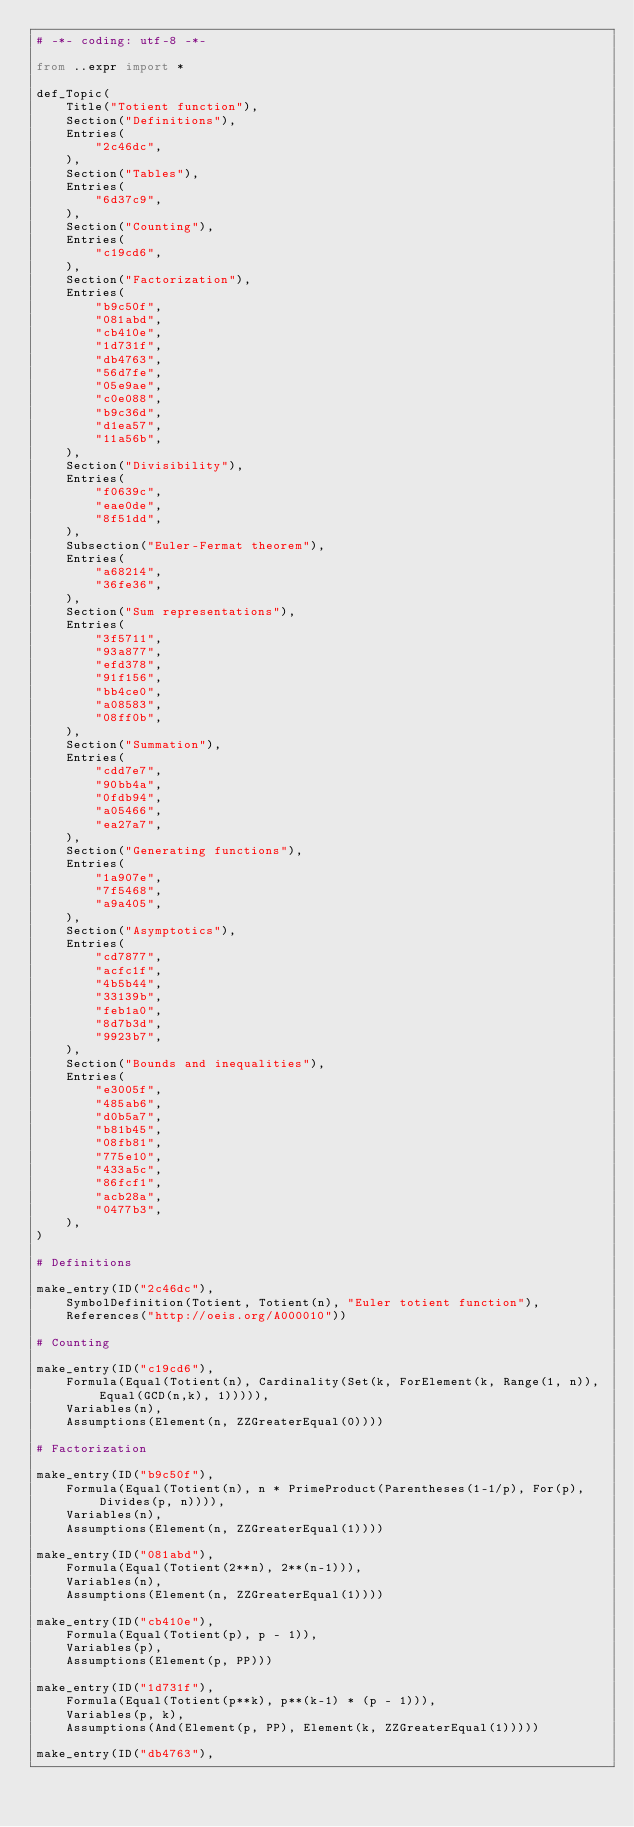<code> <loc_0><loc_0><loc_500><loc_500><_Python_># -*- coding: utf-8 -*-

from ..expr import *

def_Topic(
    Title("Totient function"),
    Section("Definitions"),
    Entries(
        "2c46dc",
    ),
    Section("Tables"),
    Entries(
        "6d37c9",
    ),
    Section("Counting"),
    Entries(
        "c19cd6",
    ),
    Section("Factorization"),
    Entries(
        "b9c50f",
        "081abd",
        "cb410e",
        "1d731f",
        "db4763",
        "56d7fe",
        "05e9ae",
        "c0e088",
        "b9c36d",
        "d1ea57",
        "11a56b",
    ),
    Section("Divisibility"),
    Entries(
        "f0639c",
        "eae0de",
        "8f51dd",
    ),
    Subsection("Euler-Fermat theorem"),
    Entries(
        "a68214",
        "36fe36",
    ),
    Section("Sum representations"),
    Entries(
        "3f5711",
        "93a877",
        "efd378",
        "91f156",
        "bb4ce0",
        "a08583",
        "08ff0b",
    ),
    Section("Summation"),
    Entries(
        "cdd7e7",
        "90bb4a",
        "0fdb94",
        "a05466",
        "ea27a7",
    ),
    Section("Generating functions"),
    Entries(
        "1a907e",
        "7f5468",
        "a9a405",
    ),
    Section("Asymptotics"),
    Entries(
        "cd7877",
        "acfc1f",
        "4b5b44",
        "33139b",
        "feb1a0",
        "8d7b3d",
        "9923b7",
    ),
    Section("Bounds and inequalities"),
    Entries(
        "e3005f",
        "485ab6",
        "d0b5a7",
        "b81b45",
        "08fb81",
        "775e10",
        "433a5c",
        "86fcf1",
        "acb28a",
        "0477b3",
    ),
)

# Definitions

make_entry(ID("2c46dc"),
    SymbolDefinition(Totient, Totient(n), "Euler totient function"),
    References("http://oeis.org/A000010"))

# Counting

make_entry(ID("c19cd6"),
    Formula(Equal(Totient(n), Cardinality(Set(k, ForElement(k, Range(1, n)), Equal(GCD(n,k), 1))))),
    Variables(n),
    Assumptions(Element(n, ZZGreaterEqual(0))))

# Factorization

make_entry(ID("b9c50f"),
    Formula(Equal(Totient(n), n * PrimeProduct(Parentheses(1-1/p), For(p), Divides(p, n)))),
    Variables(n),
    Assumptions(Element(n, ZZGreaterEqual(1))))

make_entry(ID("081abd"),
    Formula(Equal(Totient(2**n), 2**(n-1))),
    Variables(n),
    Assumptions(Element(n, ZZGreaterEqual(1))))

make_entry(ID("cb410e"),
    Formula(Equal(Totient(p), p - 1)),
    Variables(p),
    Assumptions(Element(p, PP)))

make_entry(ID("1d731f"),
    Formula(Equal(Totient(p**k), p**(k-1) * (p - 1))),
    Variables(p, k),
    Assumptions(And(Element(p, PP), Element(k, ZZGreaterEqual(1)))))

make_entry(ID("db4763"),</code> 